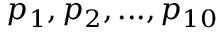Convert formula to latex. <formula><loc_0><loc_0><loc_500><loc_500>p _ { 1 } , p _ { 2 } , \dots , p _ { 1 0 }</formula> 